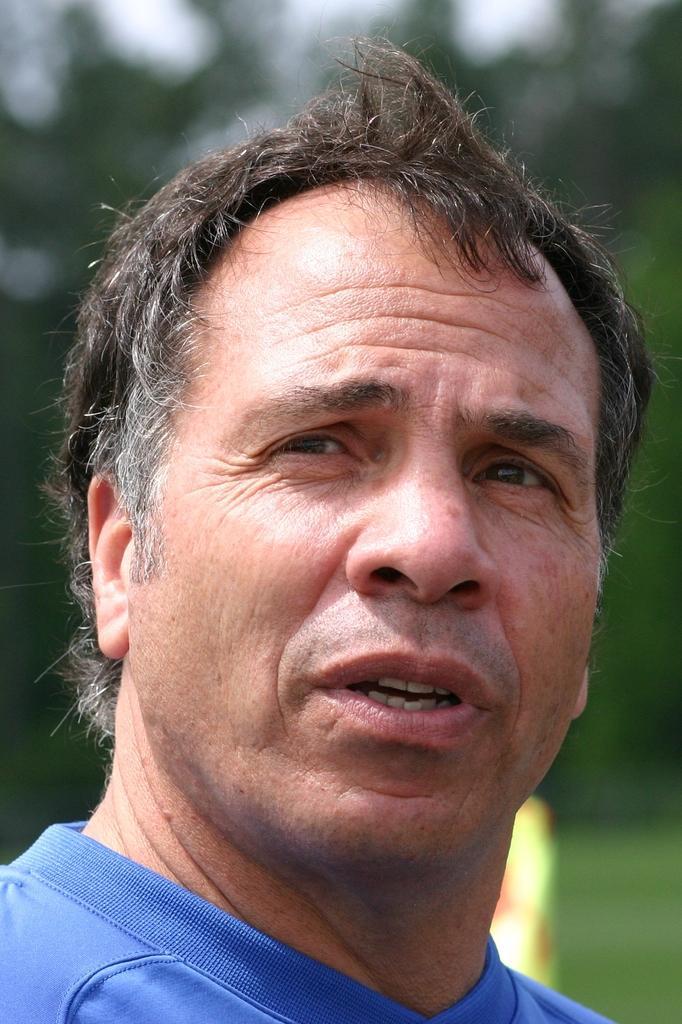In one or two sentences, can you explain what this image depicts? In this picture in the front there is a person and the background is blurry. 